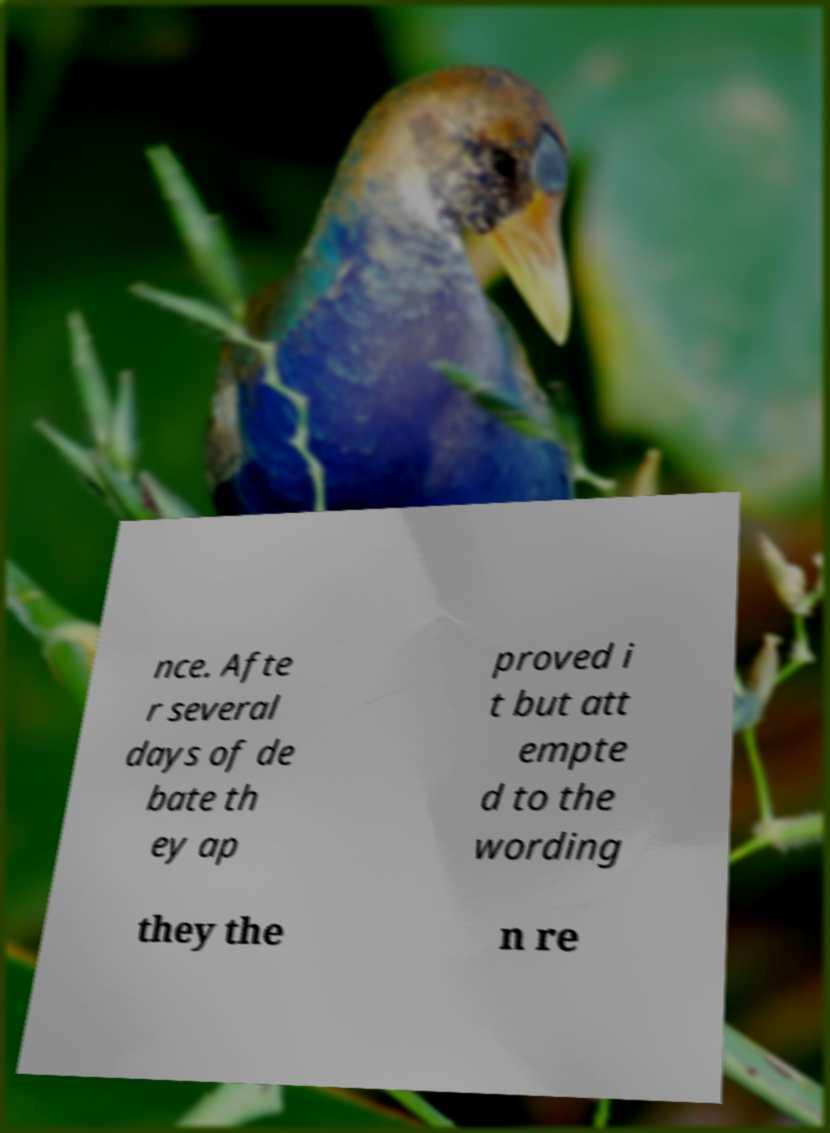For documentation purposes, I need the text within this image transcribed. Could you provide that? nce. Afte r several days of de bate th ey ap proved i t but att empte d to the wording they the n re 